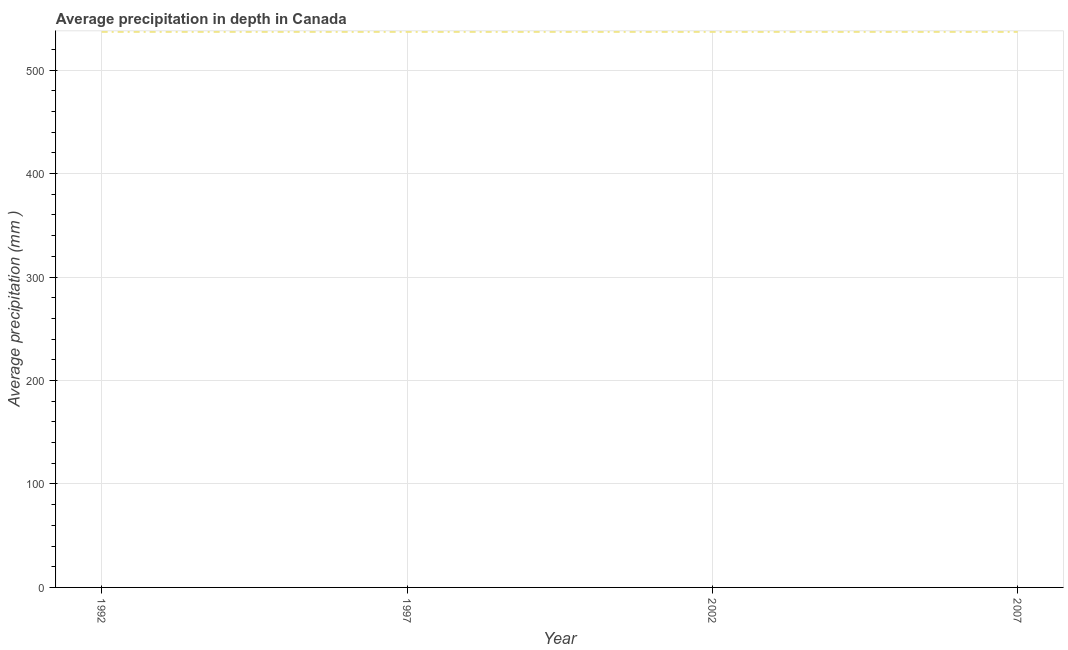What is the average precipitation in depth in 2007?
Offer a very short reply. 537. Across all years, what is the maximum average precipitation in depth?
Make the answer very short. 537. Across all years, what is the minimum average precipitation in depth?
Provide a succinct answer. 537. In which year was the average precipitation in depth maximum?
Your response must be concise. 1992. In which year was the average precipitation in depth minimum?
Offer a very short reply. 1992. What is the sum of the average precipitation in depth?
Offer a very short reply. 2148. What is the average average precipitation in depth per year?
Your response must be concise. 537. What is the median average precipitation in depth?
Provide a short and direct response. 537. Do a majority of the years between 1997 and 1992 (inclusive) have average precipitation in depth greater than 420 mm?
Keep it short and to the point. No. Is the average precipitation in depth in 1997 less than that in 2007?
Offer a very short reply. No. What is the difference between the highest and the second highest average precipitation in depth?
Your answer should be compact. 0. Is the sum of the average precipitation in depth in 2002 and 2007 greater than the maximum average precipitation in depth across all years?
Provide a short and direct response. Yes. In how many years, is the average precipitation in depth greater than the average average precipitation in depth taken over all years?
Offer a very short reply. 0. Does the graph contain grids?
Give a very brief answer. Yes. What is the title of the graph?
Your answer should be compact. Average precipitation in depth in Canada. What is the label or title of the Y-axis?
Offer a terse response. Average precipitation (mm ). What is the Average precipitation (mm ) of 1992?
Your response must be concise. 537. What is the Average precipitation (mm ) of 1997?
Give a very brief answer. 537. What is the Average precipitation (mm ) of 2002?
Provide a short and direct response. 537. What is the Average precipitation (mm ) in 2007?
Provide a succinct answer. 537. What is the difference between the Average precipitation (mm ) in 1992 and 2007?
Offer a terse response. 0. What is the difference between the Average precipitation (mm ) in 1997 and 2002?
Keep it short and to the point. 0. What is the ratio of the Average precipitation (mm ) in 1992 to that in 1997?
Provide a succinct answer. 1. What is the ratio of the Average precipitation (mm ) in 1997 to that in 2002?
Provide a short and direct response. 1. What is the ratio of the Average precipitation (mm ) in 2002 to that in 2007?
Provide a short and direct response. 1. 